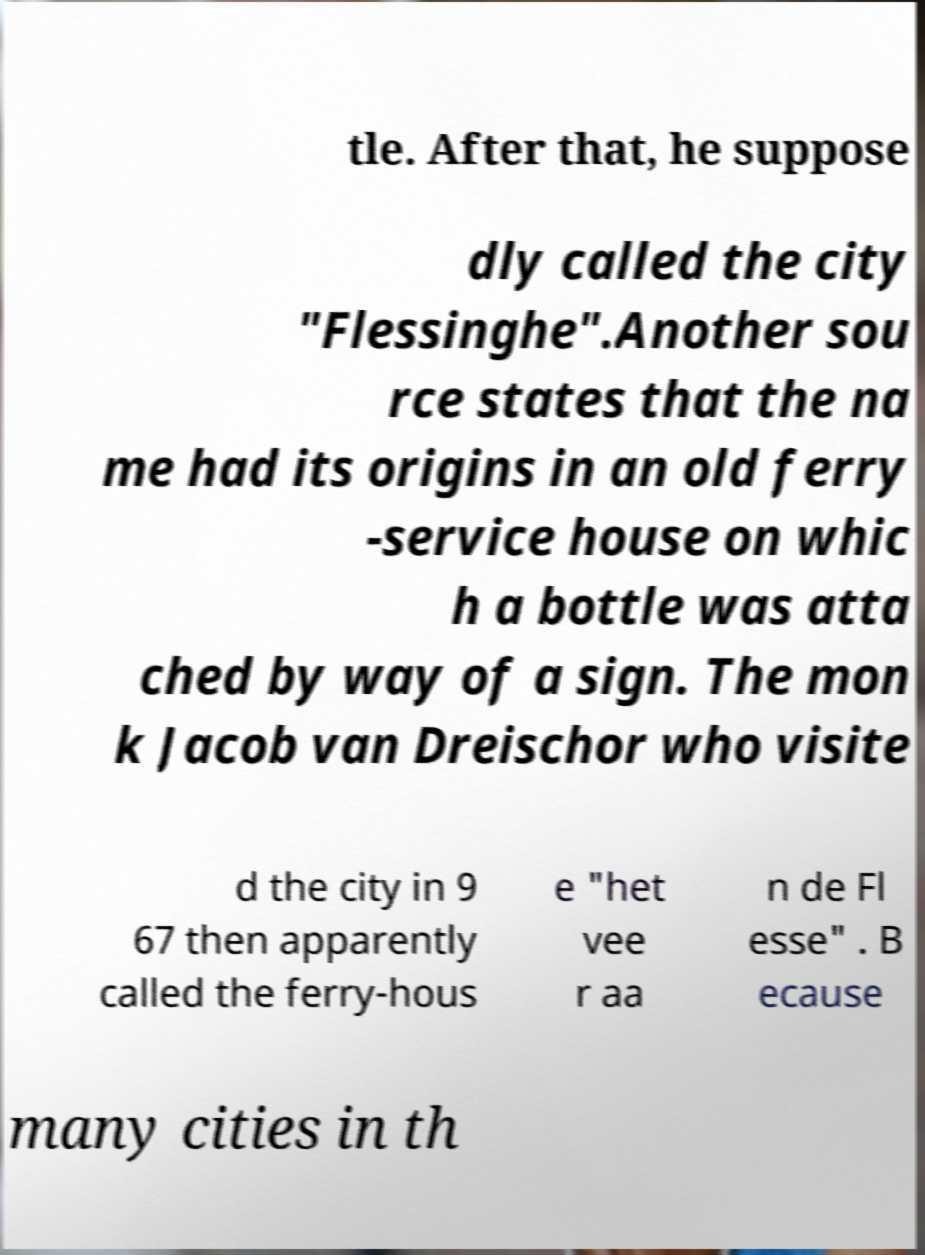For documentation purposes, I need the text within this image transcribed. Could you provide that? tle. After that, he suppose dly called the city "Flessinghe".Another sou rce states that the na me had its origins in an old ferry -service house on whic h a bottle was atta ched by way of a sign. The mon k Jacob van Dreischor who visite d the city in 9 67 then apparently called the ferry-hous e "het vee r aa n de Fl esse" . B ecause many cities in th 